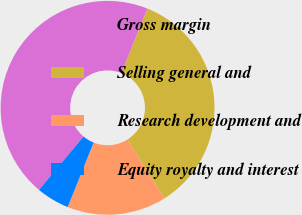Convert chart. <chart><loc_0><loc_0><loc_500><loc_500><pie_chart><fcel>Gross margin<fcel>Selling general and<fcel>Research development and<fcel>Equity royalty and interest<nl><fcel>45.0%<fcel>35.0%<fcel>15.0%<fcel>5.0%<nl></chart> 